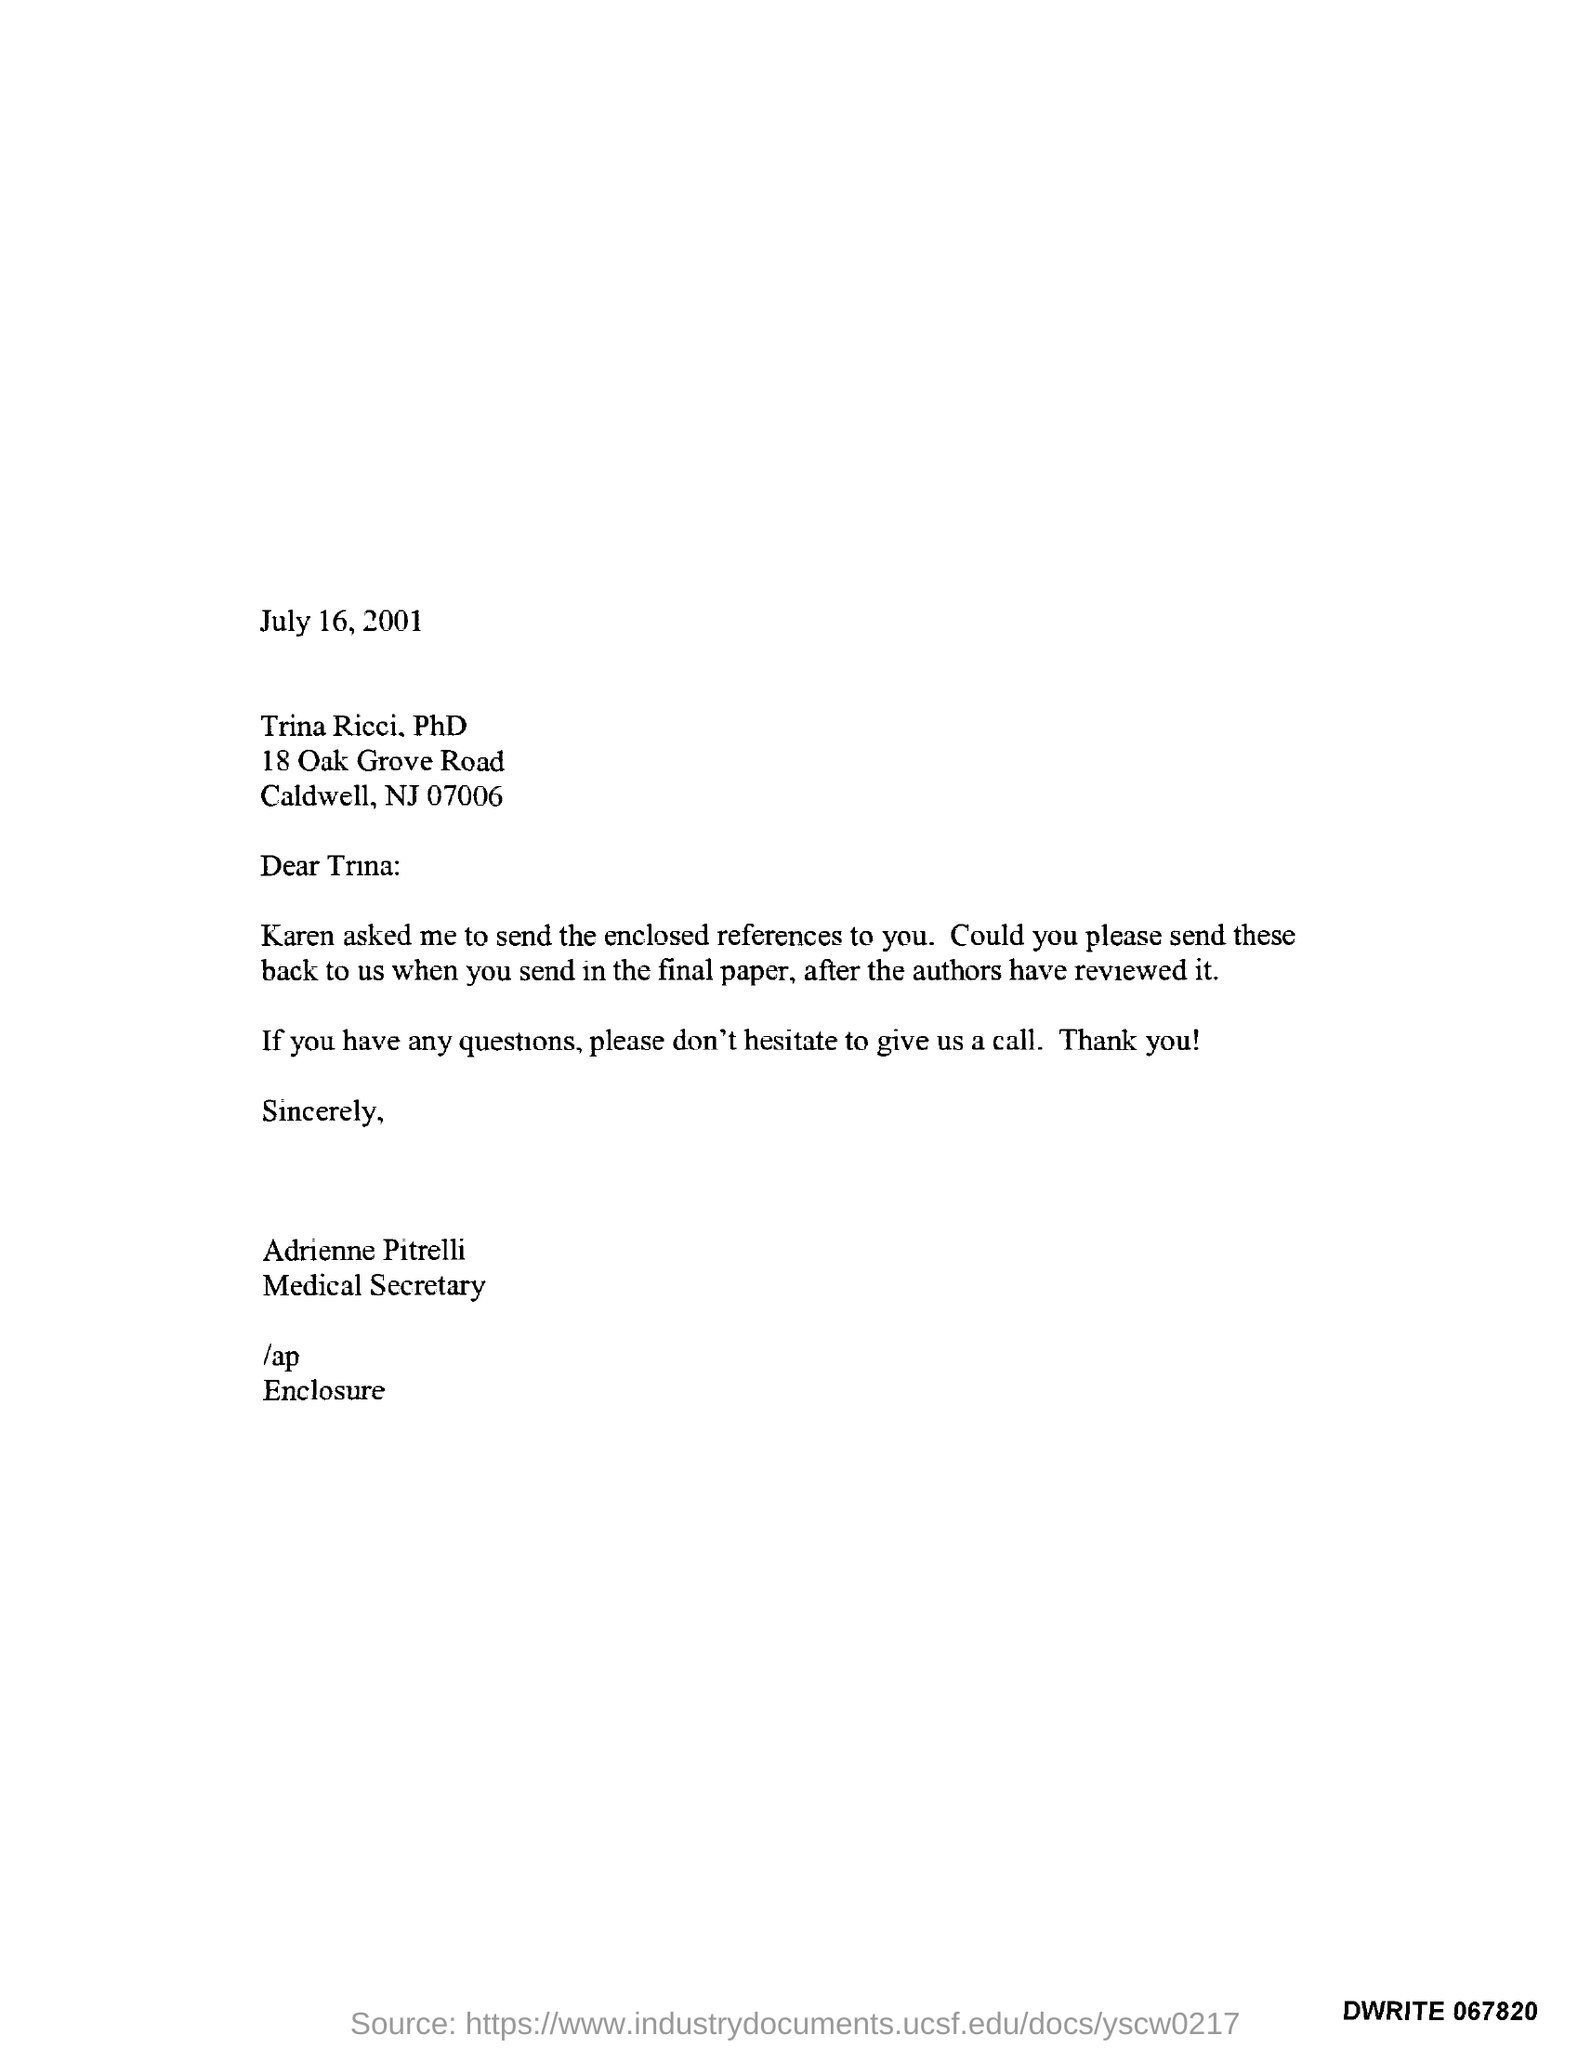Outline some significant characteristics in this image. The individual known as Adrienne Pitrelli is referred to as the Medical Secretary. 